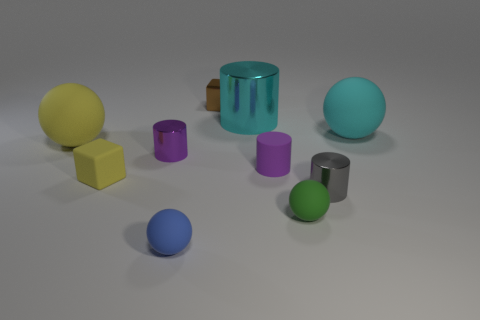What number of spheres are brown metallic things or big shiny things?
Ensure brevity in your answer.  0. There is a matte sphere that is the same color as the big cylinder; what is its size?
Your response must be concise. Large. Are there fewer gray metallic objects that are on the right side of the green matte thing than large brown shiny cylinders?
Offer a terse response. No. The thing that is in front of the small yellow matte thing and left of the metal cube is what color?
Your answer should be compact. Blue. What number of other things are the same shape as the small purple rubber object?
Offer a very short reply. 3. Are there fewer large cyan shiny cylinders in front of the gray metallic cylinder than tiny purple things in front of the big yellow sphere?
Keep it short and to the point. Yes. Do the tiny green sphere and the yellow thing left of the tiny yellow cube have the same material?
Ensure brevity in your answer.  Yes. Is there any other thing that is the same material as the blue object?
Ensure brevity in your answer.  Yes. Is the number of purple cylinders greater than the number of small red rubber cylinders?
Ensure brevity in your answer.  Yes. There is a big rubber object in front of the large ball that is to the right of the big matte sphere left of the tiny yellow thing; what is its shape?
Your answer should be compact. Sphere. 